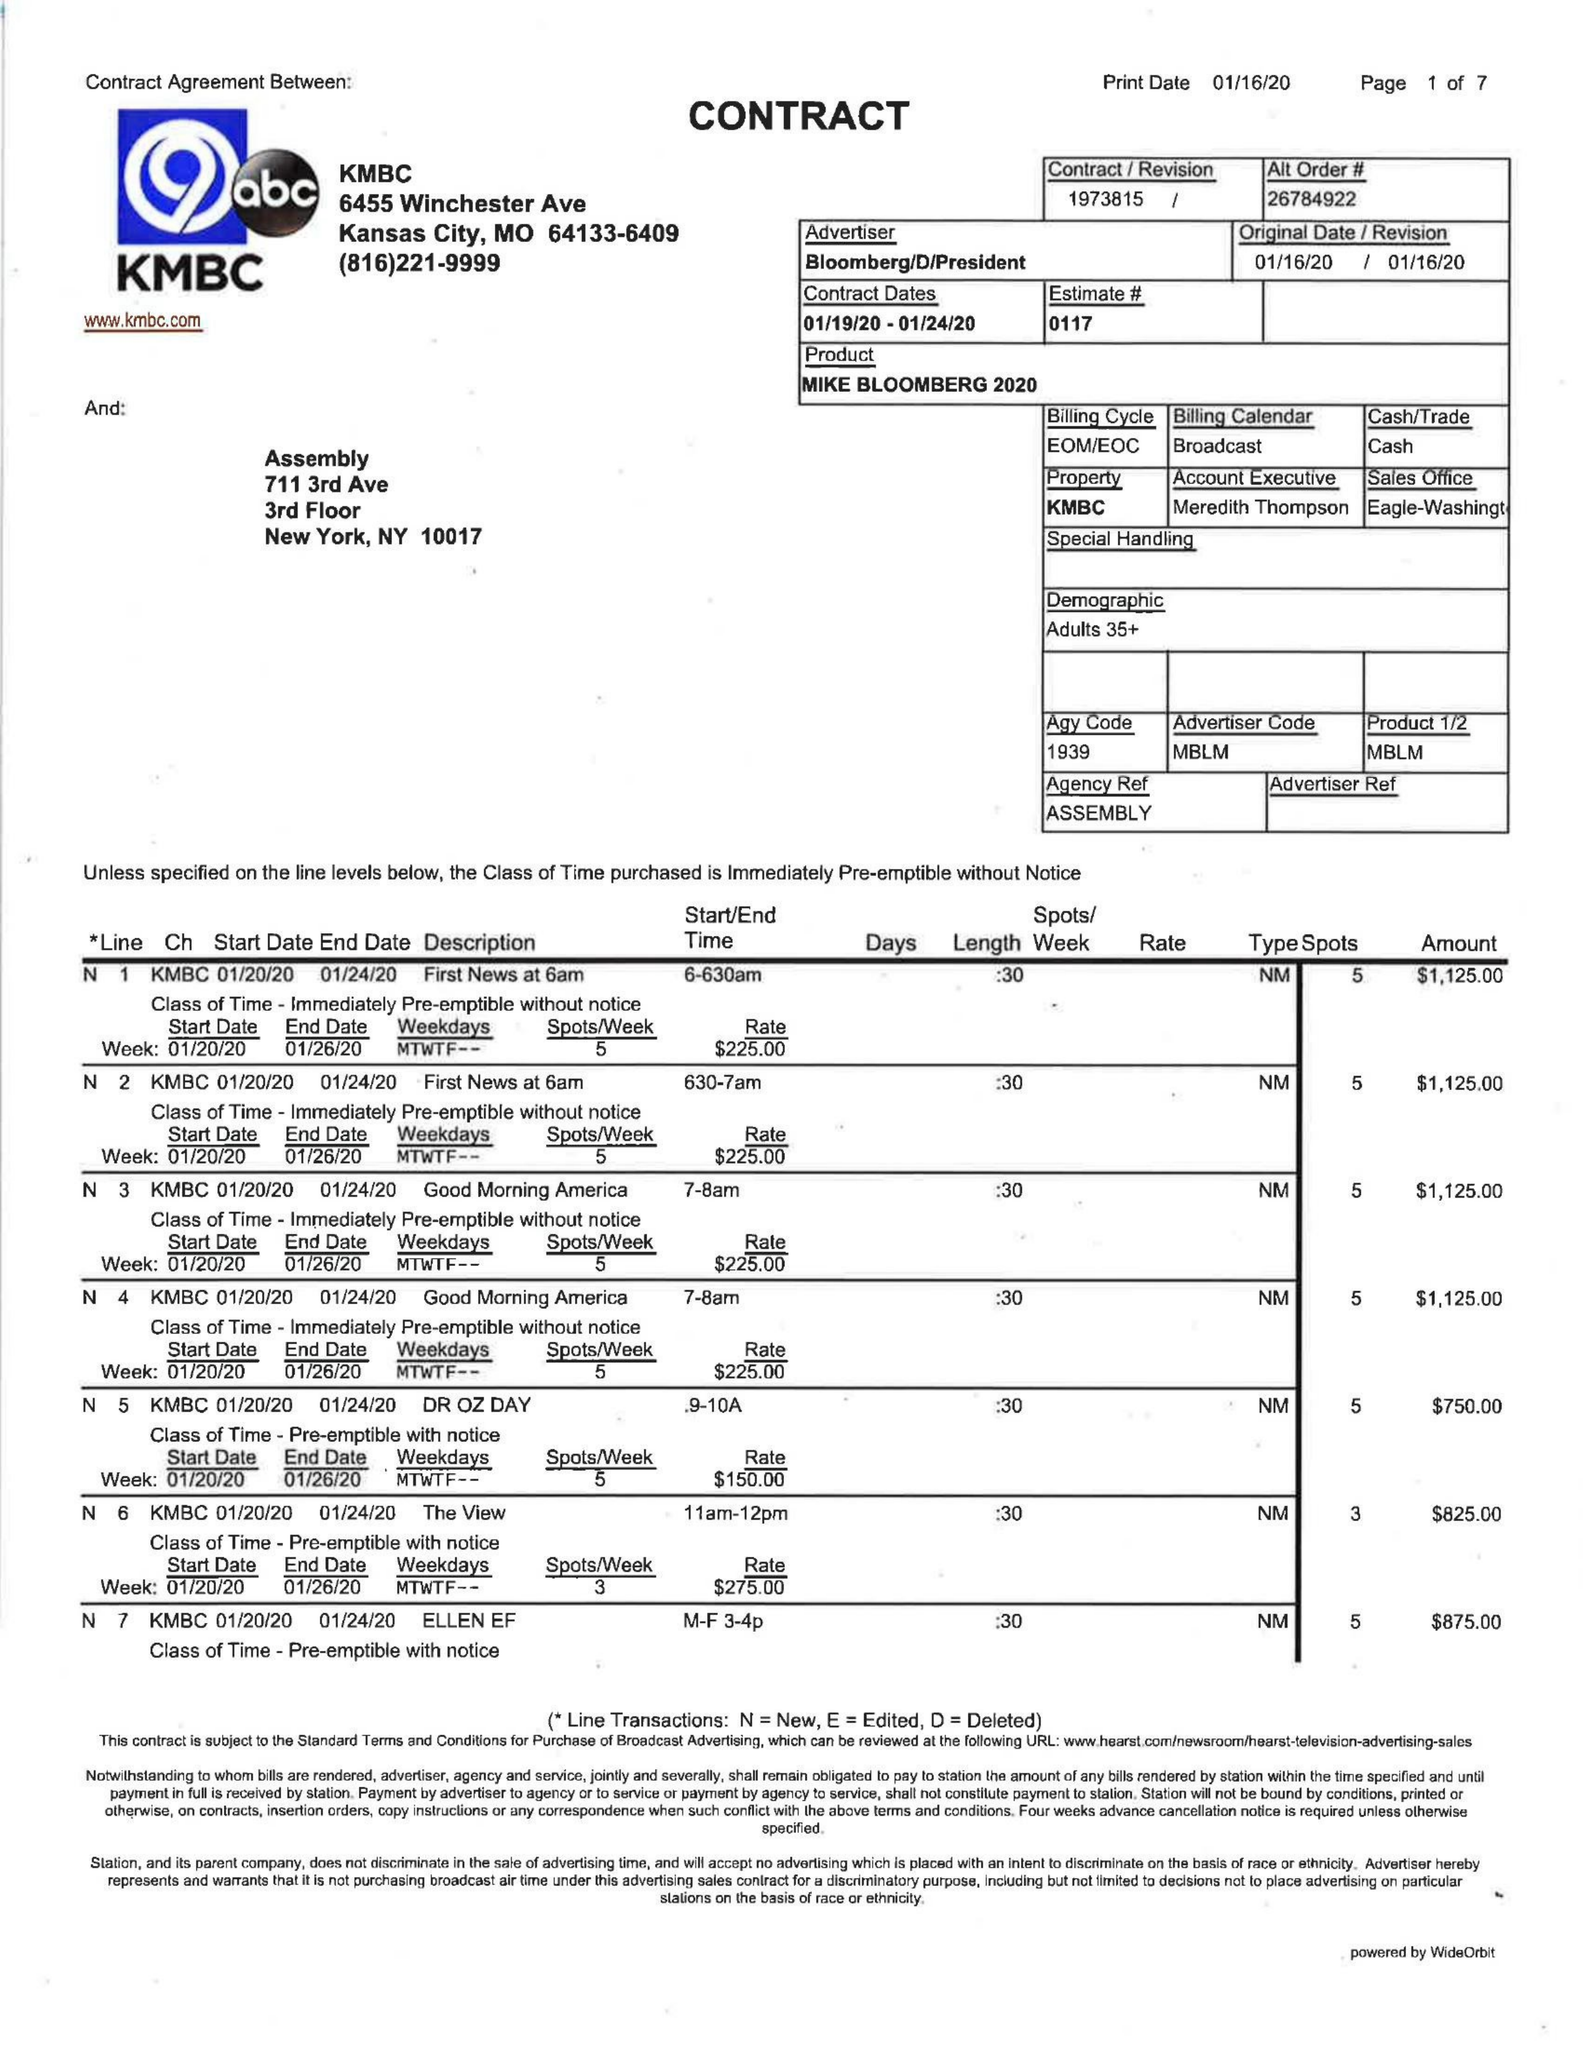What is the value for the gross_amount?
Answer the question using a single word or phrase. 22500.00 